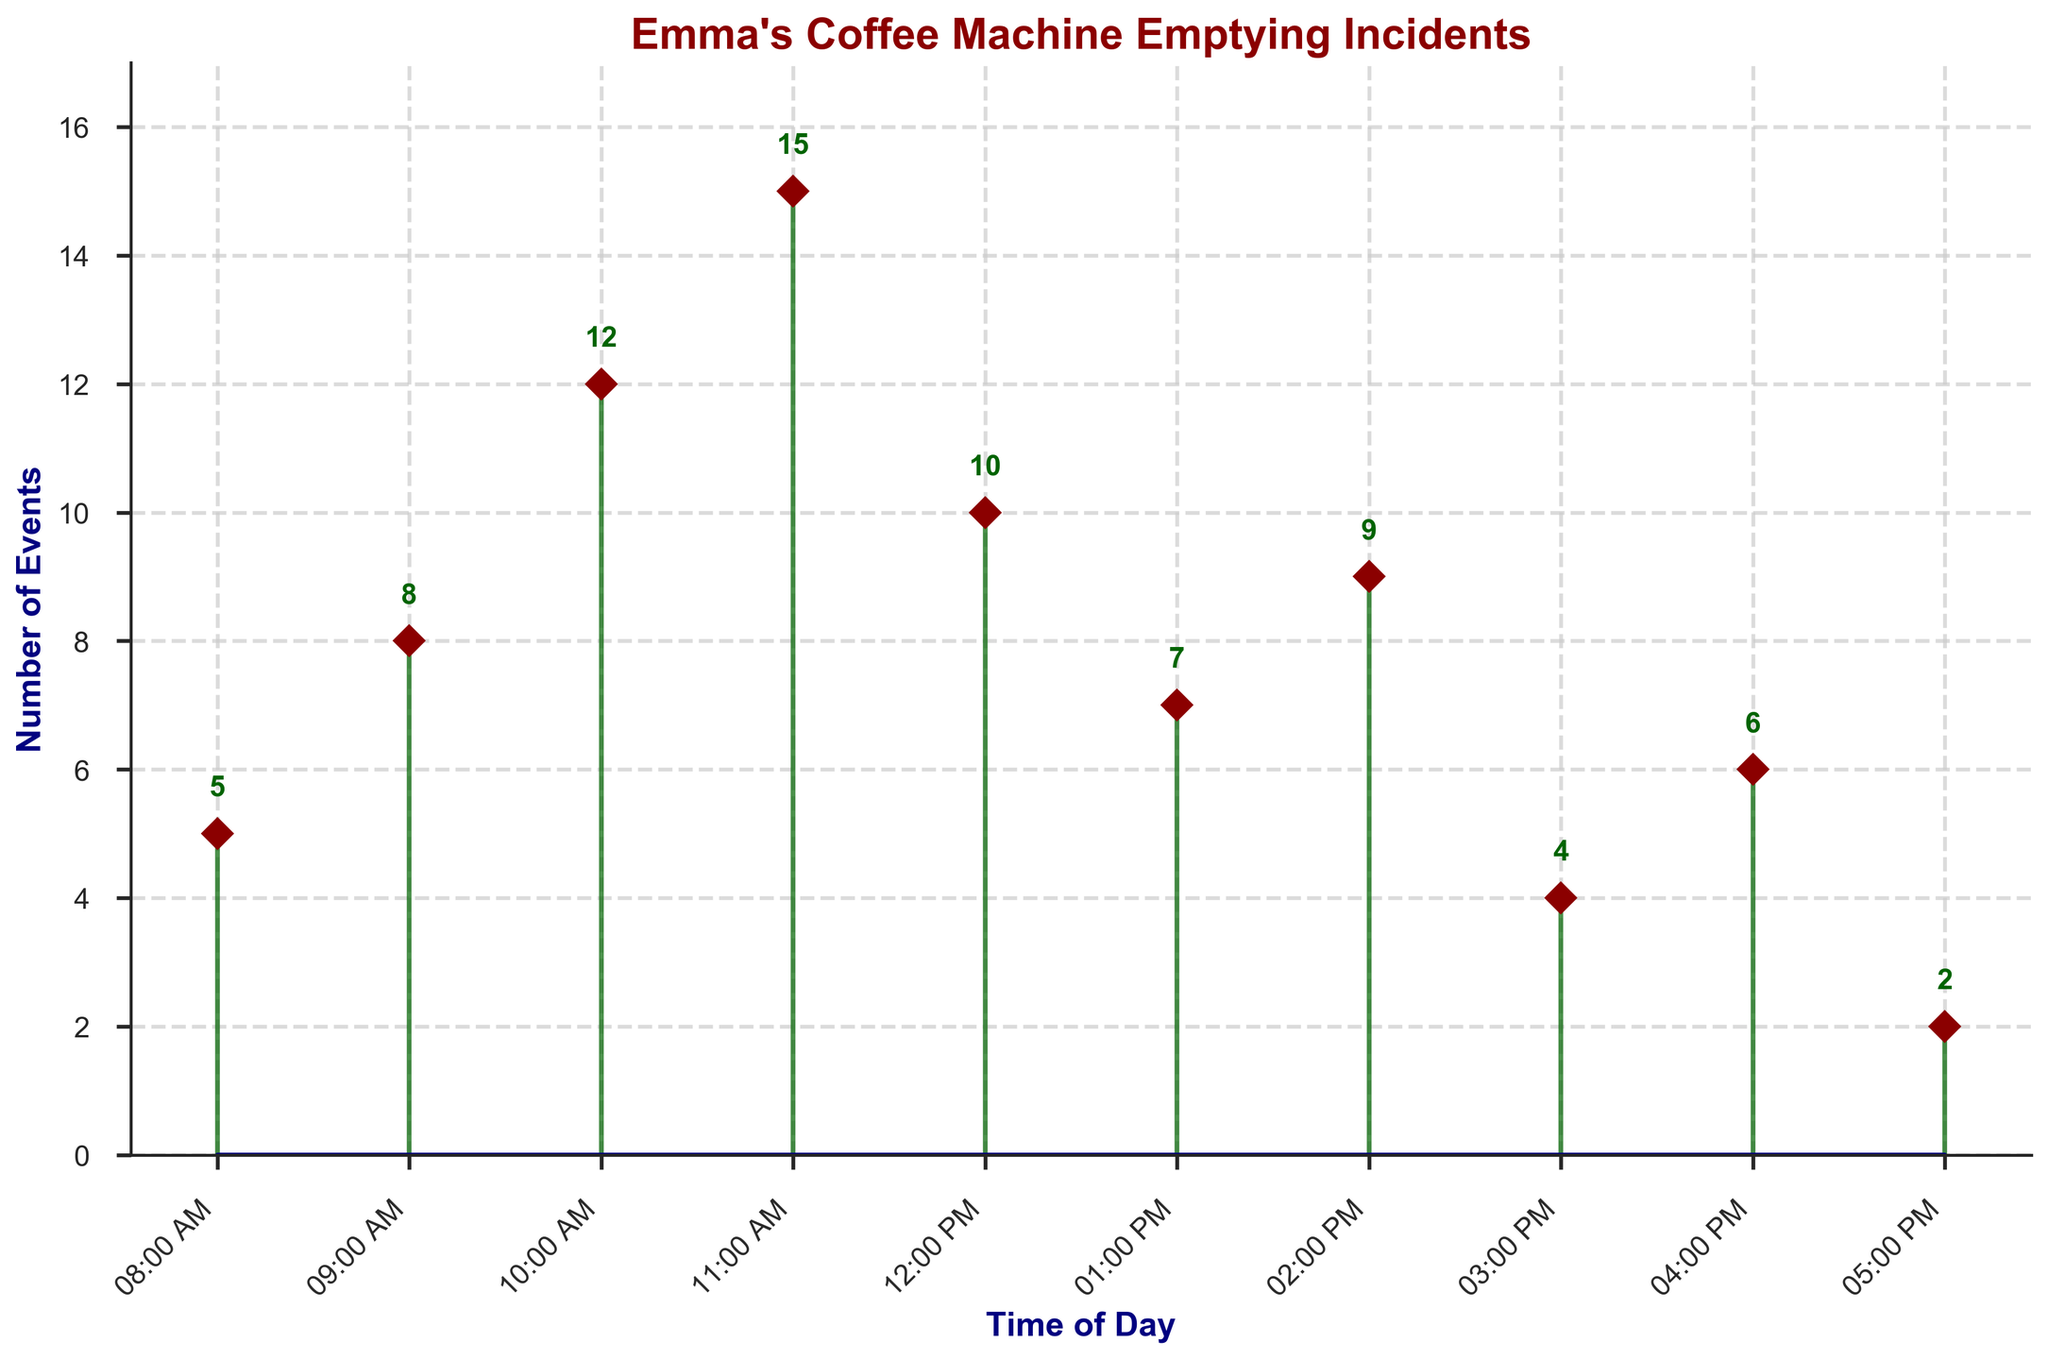What is the title of the plot? The title of the plot is usually located at the top and is often in larger font size or bolded to stand out. In this figure, the title is clearly written at the top.
Answer: "Emma's Coffee Machine Emptying Incidents" What are the labels for the x-axis and y-axis? The labels for the axes provide information about what each axis represents. In this figure, the x-axis label is located horizontally below the x-axis, and the y-axis label is placed vertically along the y-axis.
Answer: The x-axis is "Time of Day" and the y-axis is "Number of Events" Which time of day has the highest number of events? To find the time of day with the highest number of events, look for the tallest stem in the plot and identify its corresponding time label along the x-axis.
Answer: 11:00 AM How many events occurred at 09:00 AM? Locate the stem corresponding to 09:00 AM on the x-axis and look at the value it reaches on the y-axis or the text annotation above it.
Answer: 8 In which time interval does the number of events first exceed 10? To find this, observe the stems from left to right and note when they surpass the value of 10 on the y-axis.
Answer: 10:00 AM What is the sum of the events from 10:00 AM to 11:00 AM? Add the number of events at 10:00 AM and 11:00 AM. These values are 12 and 15 respectively.
Answer: The sum is 12 + 15 = 27 What's the difference in the number of events between 12:00 PM and 01:00 PM? Subtract the number of events at 01:00 PM from the number at 12:00 PM. These values are 10 and 7 respectively.
Answer: The difference is 10 - 7 = 3 What is the average number of events from 08:00 AM to 12:00 PM? Sum the events from 08:00 AM to 12:00 PM and divide by the number of times (5 time slots). The values are 5, 8, 12, 15, and 10.
Answer: The average is (5 + 8 + 12 + 15 + 10) / 5 = 10 Which times of day have fewer than 5 events? Identify the stems shorter than 5 units along the y-axis and note their corresponding times of day on the x-axis.
Answer: 05:00 PM Does the number of events at 02:00 PM differ significantly from 03:00 PM? Calculate the difference between the number of events at 02:00 PM (9) and 03:00 PM (4) and assess whether the difference is substantial (e.g., greater than or equal to 5).
Answer: Yes, the difference is 5 